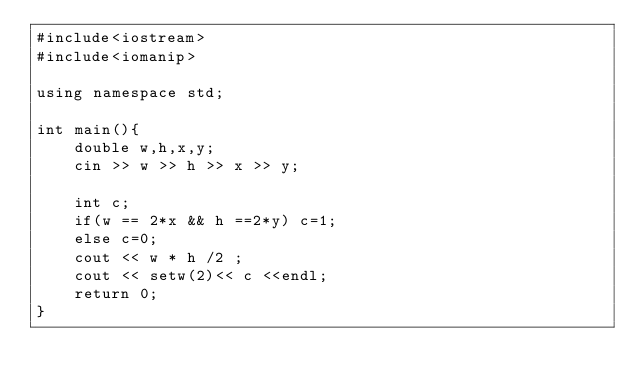<code> <loc_0><loc_0><loc_500><loc_500><_C++_>#include<iostream>
#include<iomanip>

using namespace std;

int main(){
    double w,h,x,y;
    cin >> w >> h >> x >> y;

    int c;
    if(w == 2*x && h ==2*y) c=1;
    else c=0;
    cout << w * h /2 ;
    cout << setw(2)<< c <<endl;
    return 0;
}</code> 